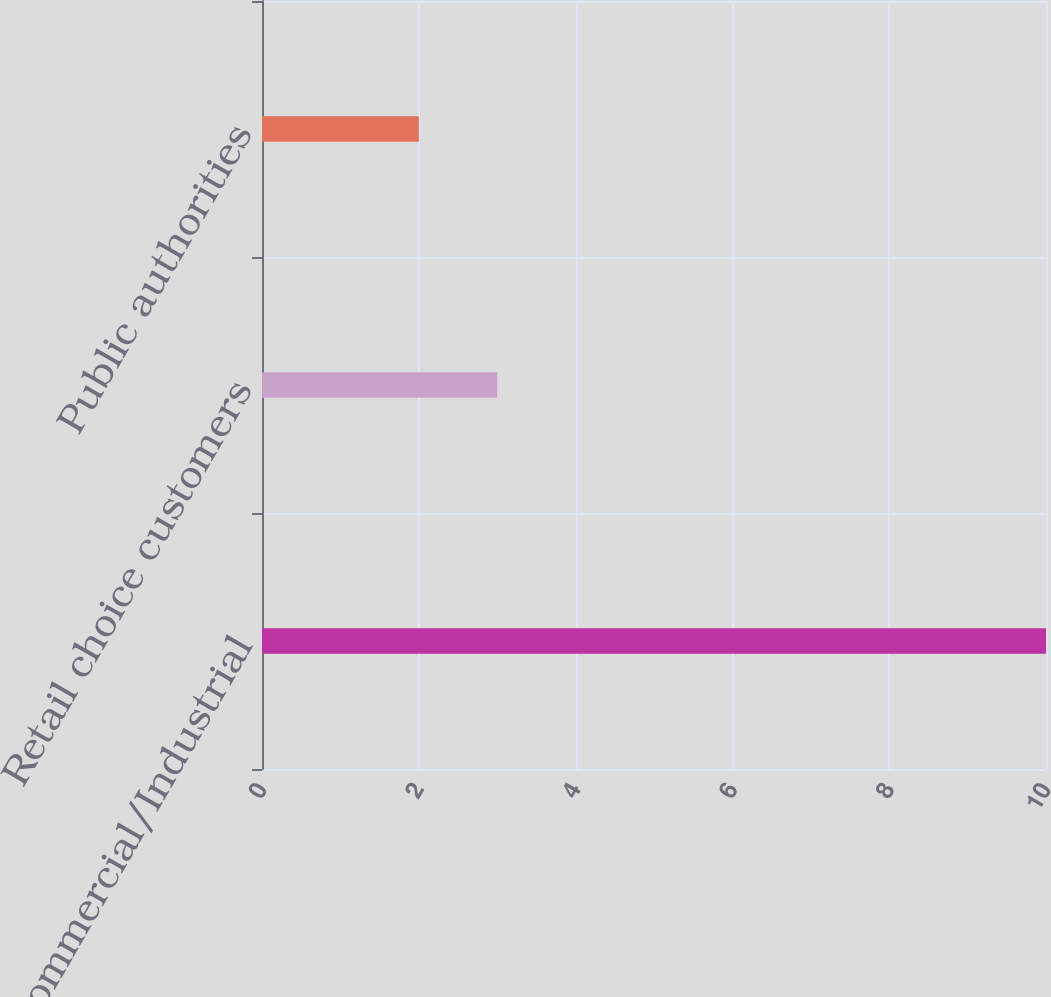Convert chart to OTSL. <chart><loc_0><loc_0><loc_500><loc_500><bar_chart><fcel>Commercial/Industrial<fcel>Retail choice customers<fcel>Public authorities<nl><fcel>10<fcel>3<fcel>2<nl></chart> 